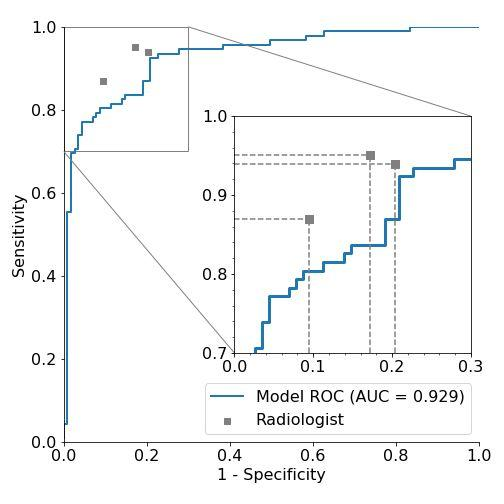What could be the possible real-world scenarios this model is evaluating according to the sensitivity and specificity shown in the ROC curve? The ROC curve in this image appears to compare the detection capabilities of a model versus a radiologist, likely in a medical imaging context, perhaps for detecting a specific disease or condition. Given the nature of both sensitivity (true positive rate) and specificity (true negative rate), this model could be used for diagnosing conditions where accurate detection has significant implications, such as cancers or other critical diseases. The model’s high AUC demonstrates its strong ability to distinguish between patients with and without the disease compared to the radiologist's assessment. 